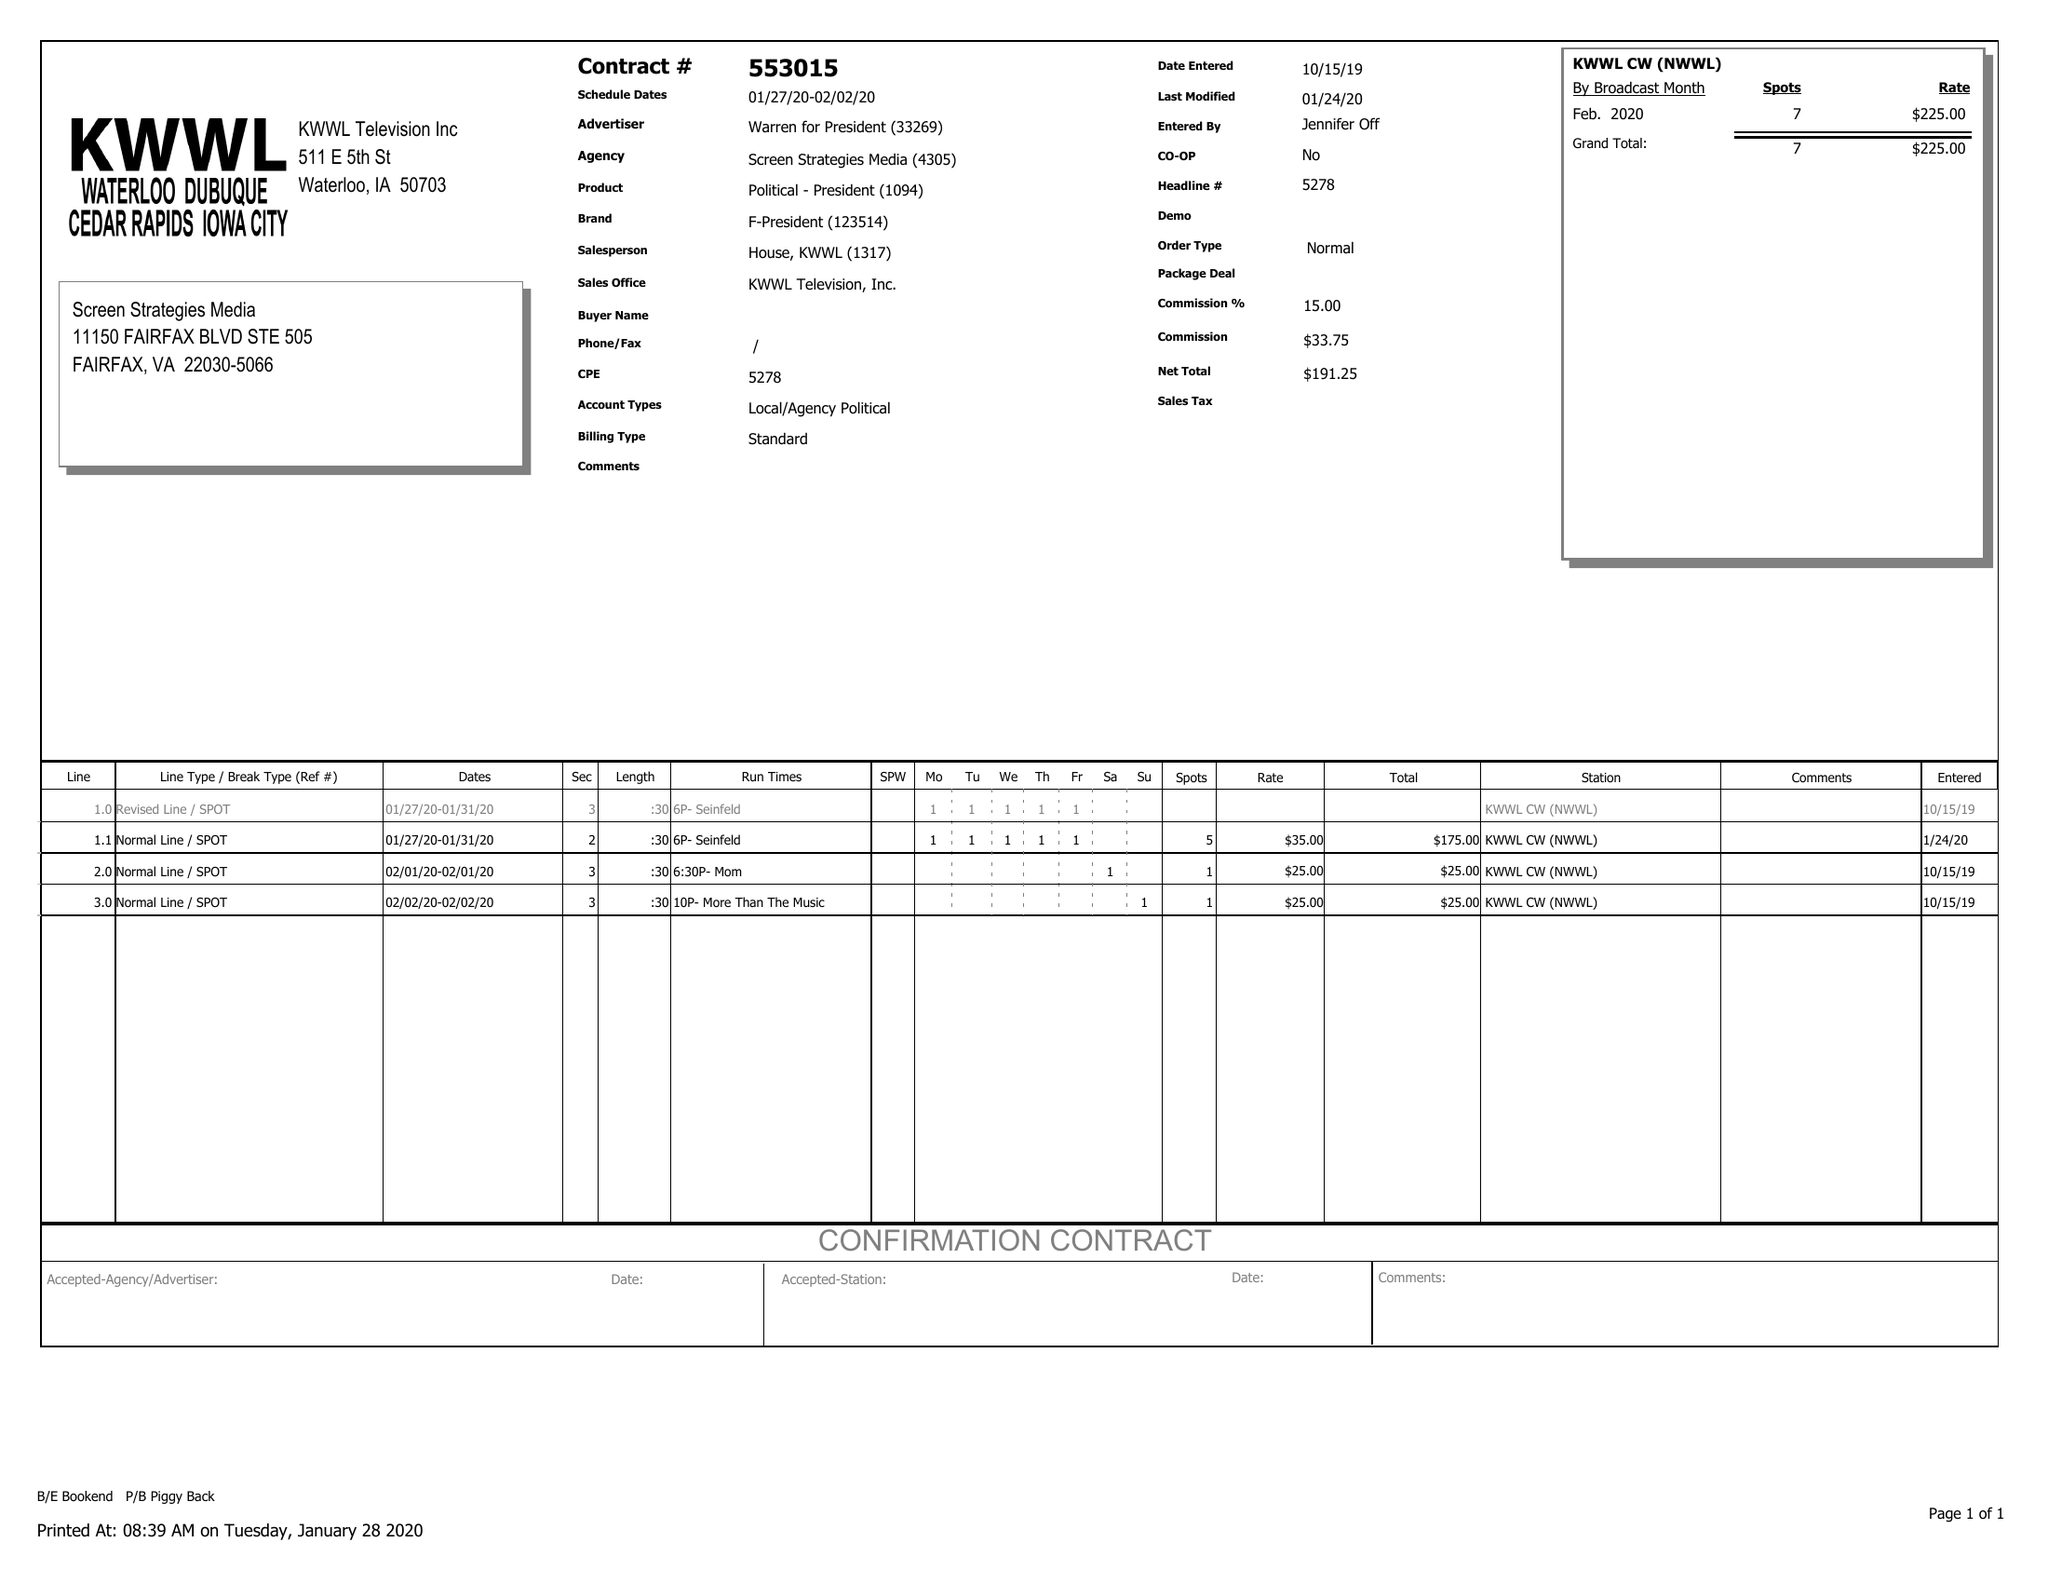What is the value for the contract_num?
Answer the question using a single word or phrase. 553015 